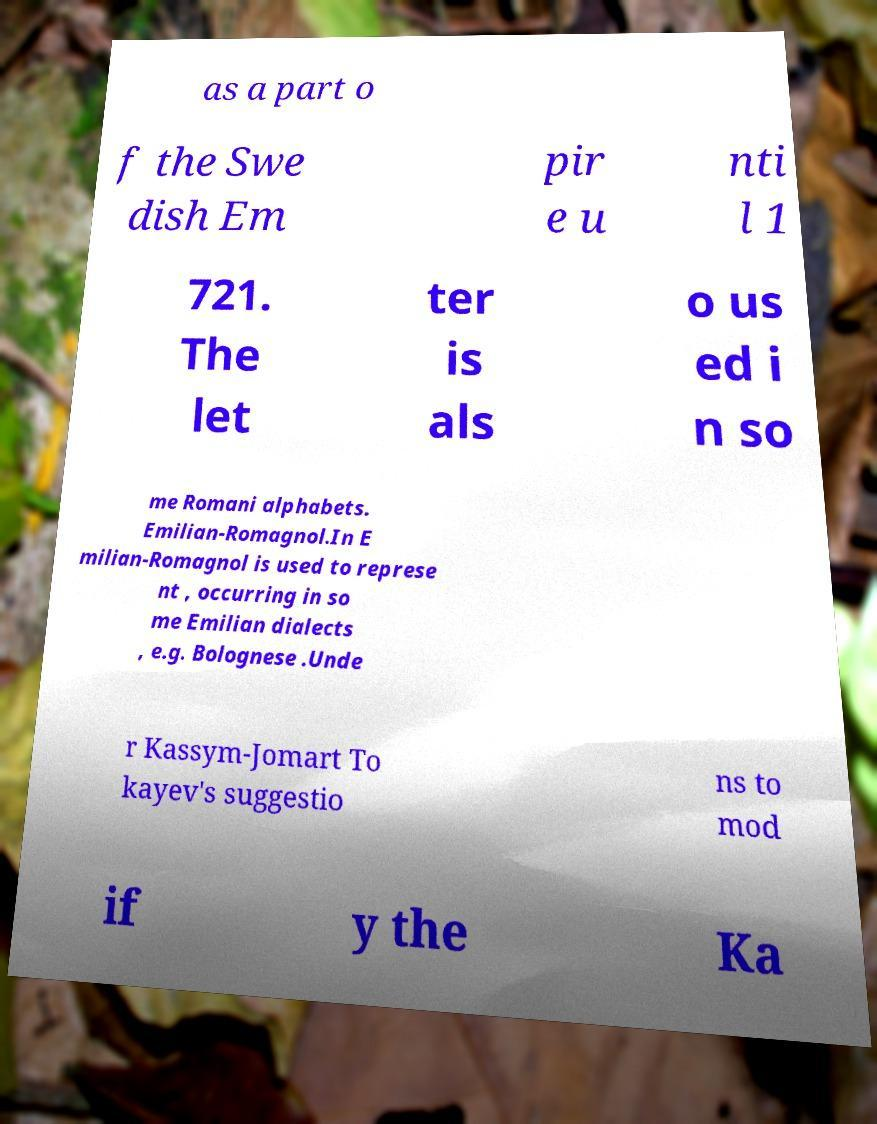There's text embedded in this image that I need extracted. Can you transcribe it verbatim? as a part o f the Swe dish Em pir e u nti l 1 721. The let ter is als o us ed i n so me Romani alphabets. Emilian-Romagnol.In E milian-Romagnol is used to represe nt , occurring in so me Emilian dialects , e.g. Bolognese .Unde r Kassym-Jomart To kayev's suggestio ns to mod if y the Ka 